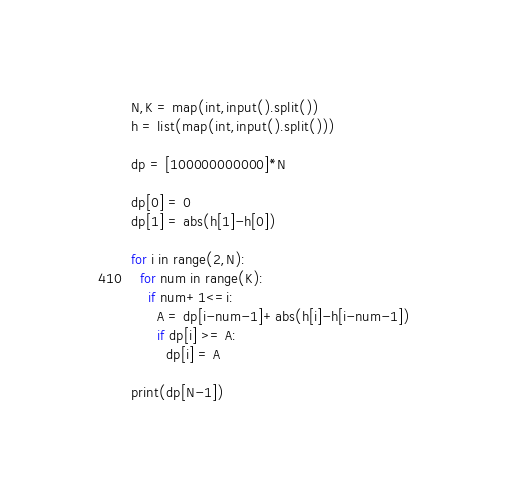<code> <loc_0><loc_0><loc_500><loc_500><_Python_>N,K = map(int,input().split())
h = list(map(int,input().split()))
 
dp = [100000000000]*N
 
dp[0] = 0
dp[1] = abs(h[1]-h[0])
 
for i in range(2,N):
  for num in range(K):
    if num+1<=i:
      A = dp[i-num-1]+abs(h[i]-h[i-num-1])
      if dp[i] >= A:
        dp[i] = A
 
print(dp[N-1])</code> 